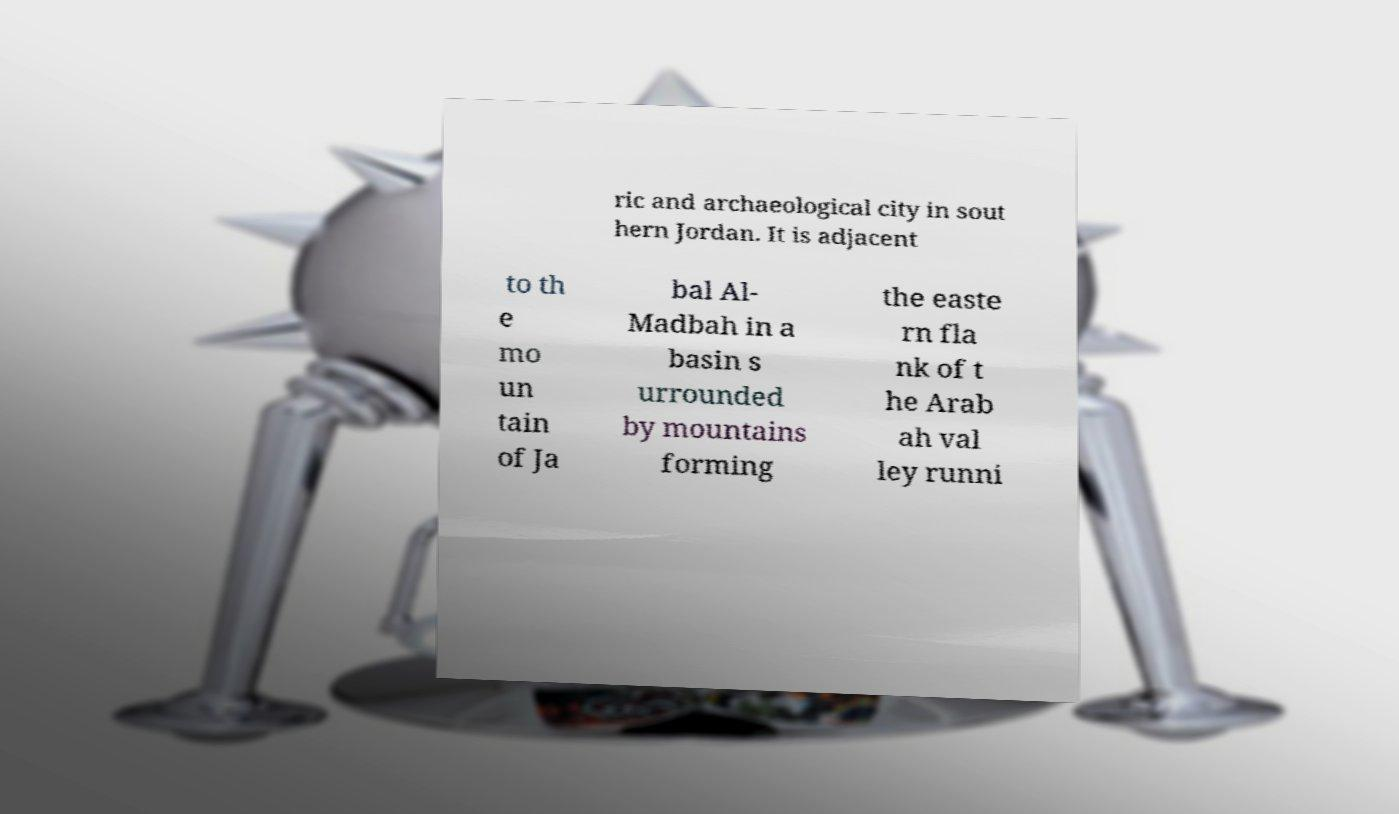For documentation purposes, I need the text within this image transcribed. Could you provide that? ric and archaeological city in sout hern Jordan. It is adjacent to th e mo un tain of Ja bal Al- Madbah in a basin s urrounded by mountains forming the easte rn fla nk of t he Arab ah val ley runni 